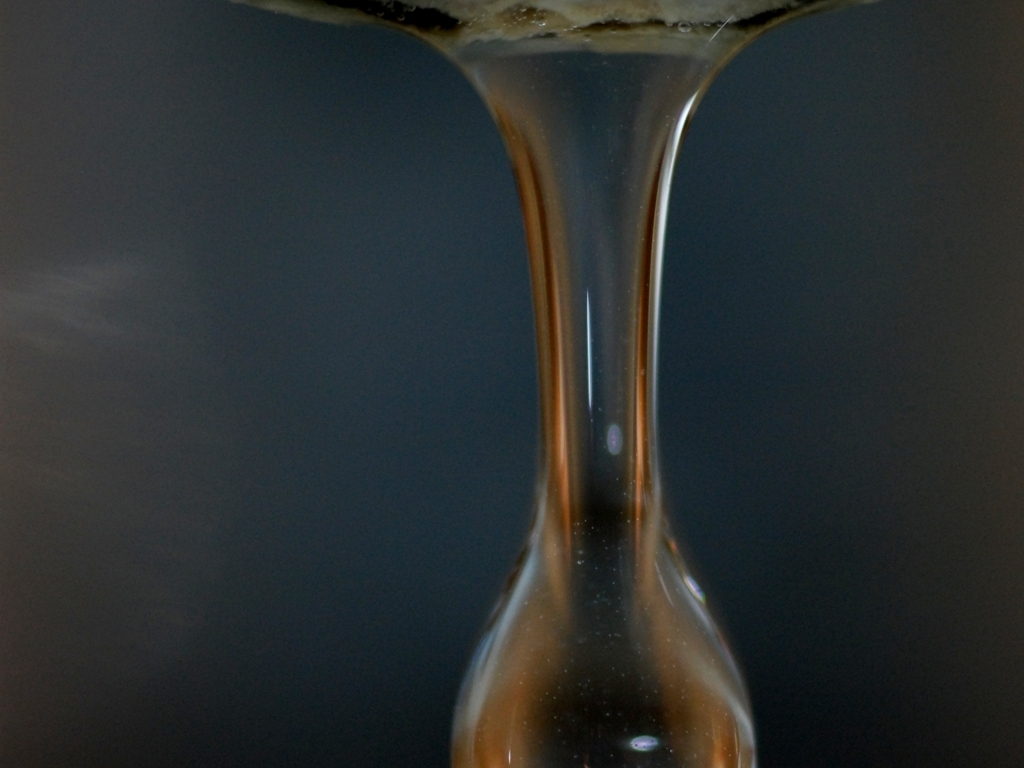How could this image be used to explain a scientific concept? The image could be used to illustrate concepts related to fluid dynamics and cohesion of liquids. For instance, it visually demonstrates surface tension, gravity's effects on liquids, and could also be associated with explanations about the viscosity properties of the fluid being depicted. 